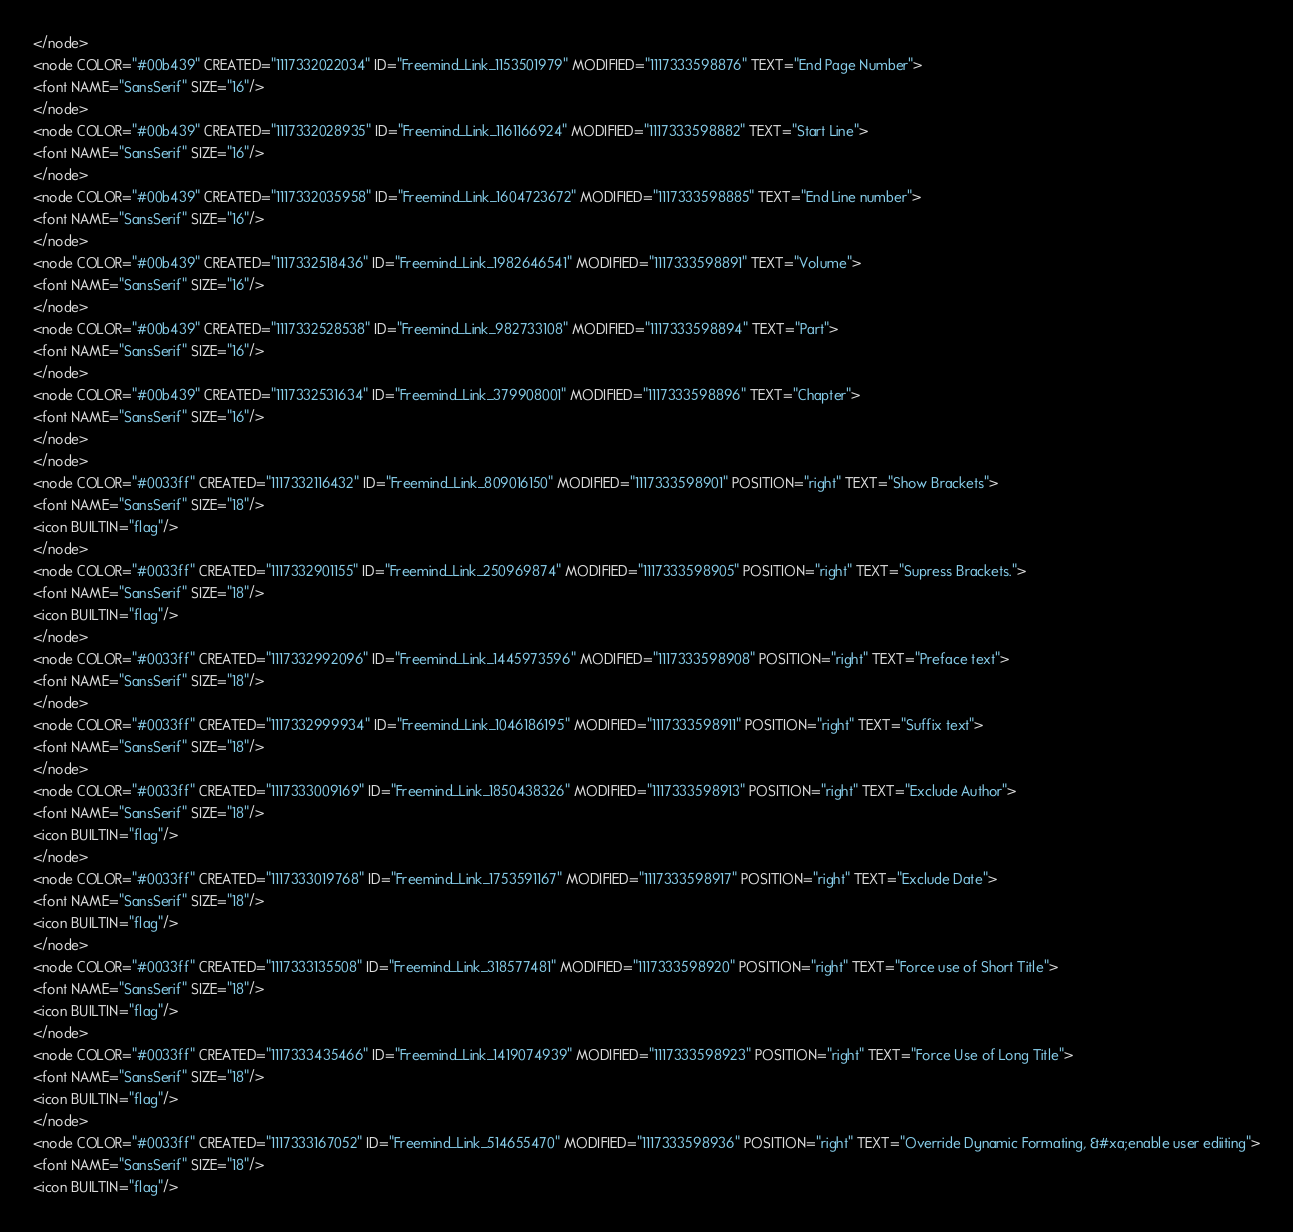<code> <loc_0><loc_0><loc_500><loc_500><_ObjectiveC_></node>
<node COLOR="#00b439" CREATED="1117332022034" ID="Freemind_Link_1153501979" MODIFIED="1117333598876" TEXT="End Page Number">
<font NAME="SansSerif" SIZE="16"/>
</node>
<node COLOR="#00b439" CREATED="1117332028935" ID="Freemind_Link_1161166924" MODIFIED="1117333598882" TEXT="Start Line">
<font NAME="SansSerif" SIZE="16"/>
</node>
<node COLOR="#00b439" CREATED="1117332035958" ID="Freemind_Link_1604723672" MODIFIED="1117333598885" TEXT="End Line number">
<font NAME="SansSerif" SIZE="16"/>
</node>
<node COLOR="#00b439" CREATED="1117332518436" ID="Freemind_Link_1982646541" MODIFIED="1117333598891" TEXT="Volume">
<font NAME="SansSerif" SIZE="16"/>
</node>
<node COLOR="#00b439" CREATED="1117332528538" ID="Freemind_Link_982733108" MODIFIED="1117333598894" TEXT="Part">
<font NAME="SansSerif" SIZE="16"/>
</node>
<node COLOR="#00b439" CREATED="1117332531634" ID="Freemind_Link_379908001" MODIFIED="1117333598896" TEXT="Chapter">
<font NAME="SansSerif" SIZE="16"/>
</node>
</node>
<node COLOR="#0033ff" CREATED="1117332116432" ID="Freemind_Link_809016150" MODIFIED="1117333598901" POSITION="right" TEXT="Show Brackets">
<font NAME="SansSerif" SIZE="18"/>
<icon BUILTIN="flag"/>
</node>
<node COLOR="#0033ff" CREATED="1117332901155" ID="Freemind_Link_250969874" MODIFIED="1117333598905" POSITION="right" TEXT="Supress Brackets.">
<font NAME="SansSerif" SIZE="18"/>
<icon BUILTIN="flag"/>
</node>
<node COLOR="#0033ff" CREATED="1117332992096" ID="Freemind_Link_1445973596" MODIFIED="1117333598908" POSITION="right" TEXT="Preface text">
<font NAME="SansSerif" SIZE="18"/>
</node>
<node COLOR="#0033ff" CREATED="1117332999934" ID="Freemind_Link_1046186195" MODIFIED="1117333598911" POSITION="right" TEXT="Suffix text">
<font NAME="SansSerif" SIZE="18"/>
</node>
<node COLOR="#0033ff" CREATED="1117333009169" ID="Freemind_Link_1850438326" MODIFIED="1117333598913" POSITION="right" TEXT="Exclude Author">
<font NAME="SansSerif" SIZE="18"/>
<icon BUILTIN="flag"/>
</node>
<node COLOR="#0033ff" CREATED="1117333019768" ID="Freemind_Link_1753591167" MODIFIED="1117333598917" POSITION="right" TEXT="Exclude Date">
<font NAME="SansSerif" SIZE="18"/>
<icon BUILTIN="flag"/>
</node>
<node COLOR="#0033ff" CREATED="1117333135508" ID="Freemind_Link_318577481" MODIFIED="1117333598920" POSITION="right" TEXT="Force use of Short Title">
<font NAME="SansSerif" SIZE="18"/>
<icon BUILTIN="flag"/>
</node>
<node COLOR="#0033ff" CREATED="1117333435466" ID="Freemind_Link_1419074939" MODIFIED="1117333598923" POSITION="right" TEXT="Force Use of Long Title">
<font NAME="SansSerif" SIZE="18"/>
<icon BUILTIN="flag"/>
</node>
<node COLOR="#0033ff" CREATED="1117333167052" ID="Freemind_Link_514655470" MODIFIED="1117333598936" POSITION="right" TEXT="Override Dynamic Formating, &#xa;enable user ediiting">
<font NAME="SansSerif" SIZE="18"/>
<icon BUILTIN="flag"/></code> 